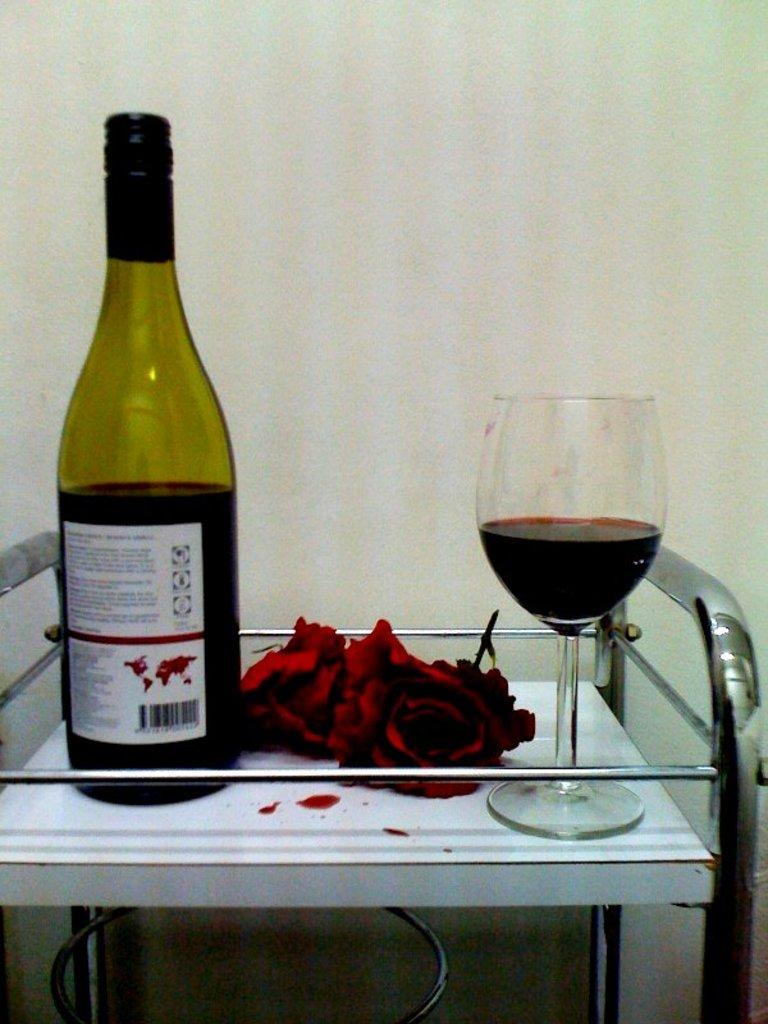What piece of furniture is present in the image? There is a stool in the image. What is placed on the stool? There are flowers, a wine glass with liquid, and a bottle on the stool. What is the purpose of the sticker on the bottle? The sticker on the bottle serves as a label or identification for the contents of the bottle. What can be seen in the background of the image? There is a wall visible in the background of the image. What type of guide is present on the shelf in the image? A: There is no shelf present in the image, and therefore no guide can be observed. 